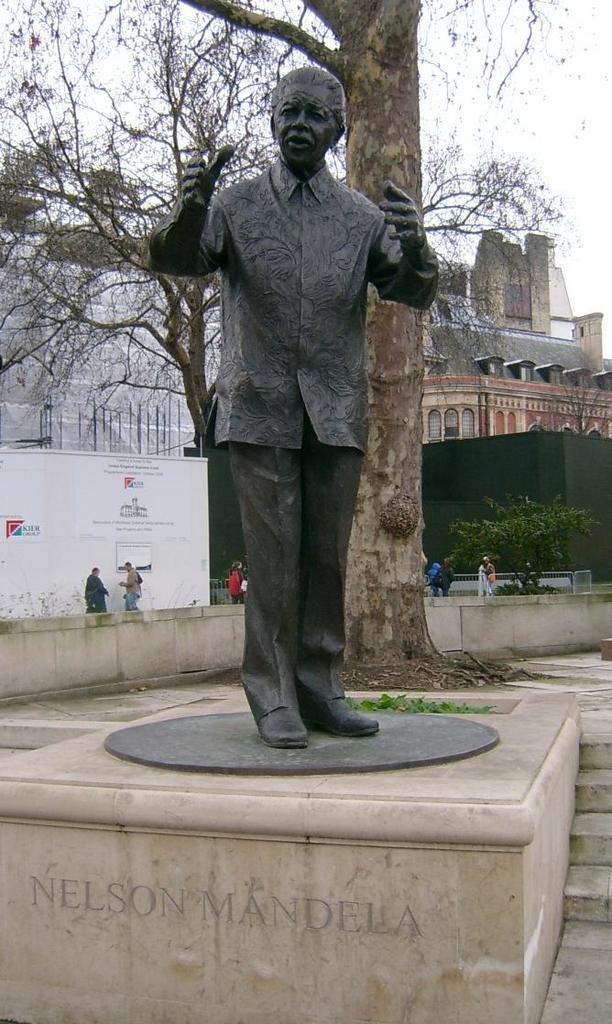Can you describe this image briefly? As we can see in the image there is a statue, few people here and there, buildings and trees. On the top there is sky. 